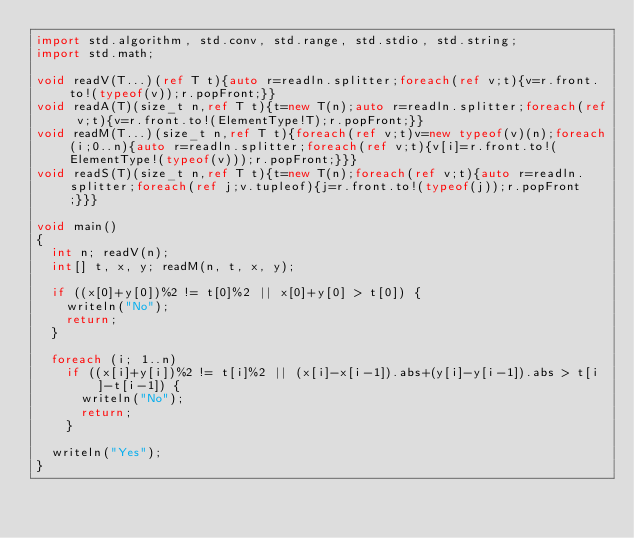<code> <loc_0><loc_0><loc_500><loc_500><_D_>import std.algorithm, std.conv, std.range, std.stdio, std.string;
import std.math;

void readV(T...)(ref T t){auto r=readln.splitter;foreach(ref v;t){v=r.front.to!(typeof(v));r.popFront;}}
void readA(T)(size_t n,ref T t){t=new T(n);auto r=readln.splitter;foreach(ref v;t){v=r.front.to!(ElementType!T);r.popFront;}}
void readM(T...)(size_t n,ref T t){foreach(ref v;t)v=new typeof(v)(n);foreach(i;0..n){auto r=readln.splitter;foreach(ref v;t){v[i]=r.front.to!(ElementType!(typeof(v)));r.popFront;}}}
void readS(T)(size_t n,ref T t){t=new T(n);foreach(ref v;t){auto r=readln.splitter;foreach(ref j;v.tupleof){j=r.front.to!(typeof(j));r.popFront;}}}

void main()
{
  int n; readV(n);
  int[] t, x, y; readM(n, t, x, y);

  if ((x[0]+y[0])%2 != t[0]%2 || x[0]+y[0] > t[0]) {
    writeln("No");
    return;
  }

  foreach (i; 1..n)
    if ((x[i]+y[i])%2 != t[i]%2 || (x[i]-x[i-1]).abs+(y[i]-y[i-1]).abs > t[i]-t[i-1]) {
      writeln("No");
      return;
    }

  writeln("Yes");
}
</code> 